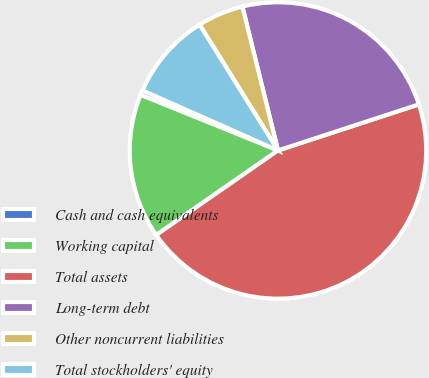Convert chart to OTSL. <chart><loc_0><loc_0><loc_500><loc_500><pie_chart><fcel>Cash and cash equivalents<fcel>Working capital<fcel>Total assets<fcel>Long-term debt<fcel>Other noncurrent liabilities<fcel>Total stockholders' equity<nl><fcel>0.52%<fcel>15.78%<fcel>45.37%<fcel>23.83%<fcel>5.01%<fcel>9.49%<nl></chart> 